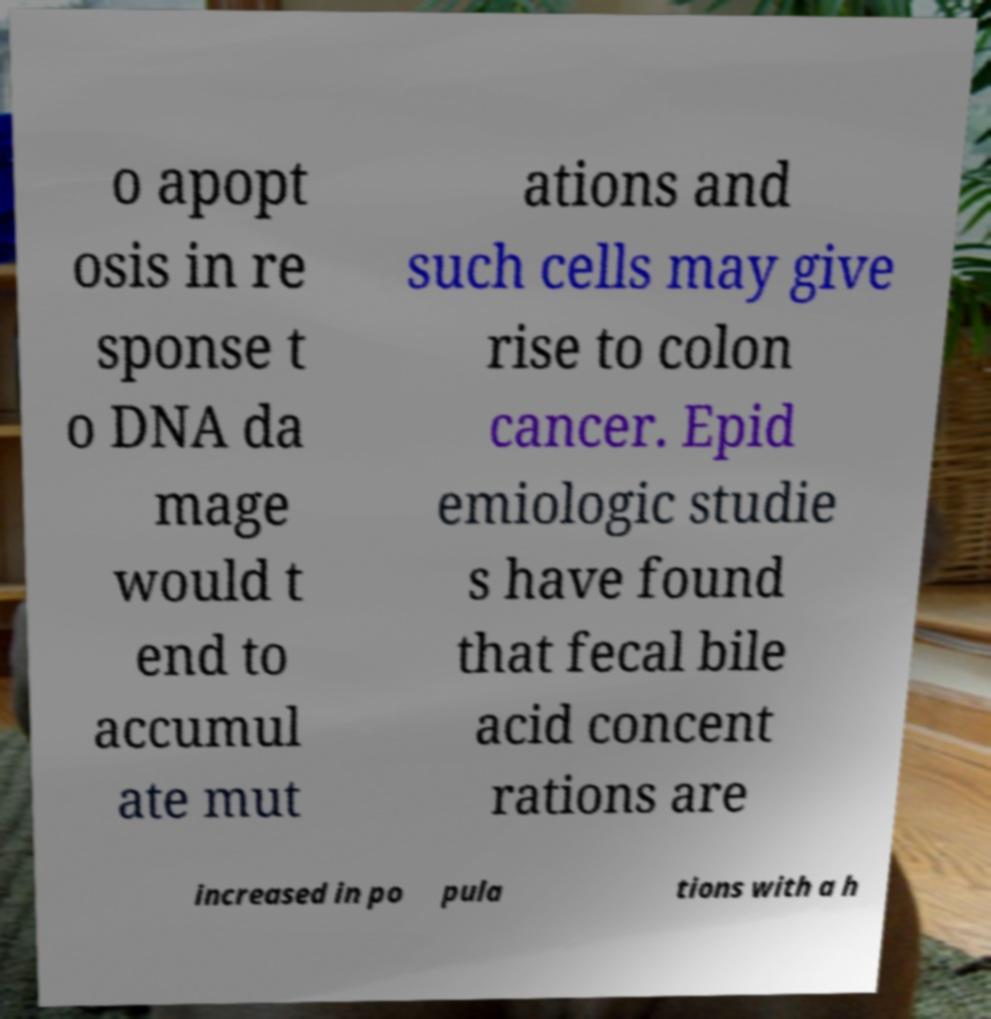There's text embedded in this image that I need extracted. Can you transcribe it verbatim? o apopt osis in re sponse t o DNA da mage would t end to accumul ate mut ations and such cells may give rise to colon cancer. Epid emiologic studie s have found that fecal bile acid concent rations are increased in po pula tions with a h 